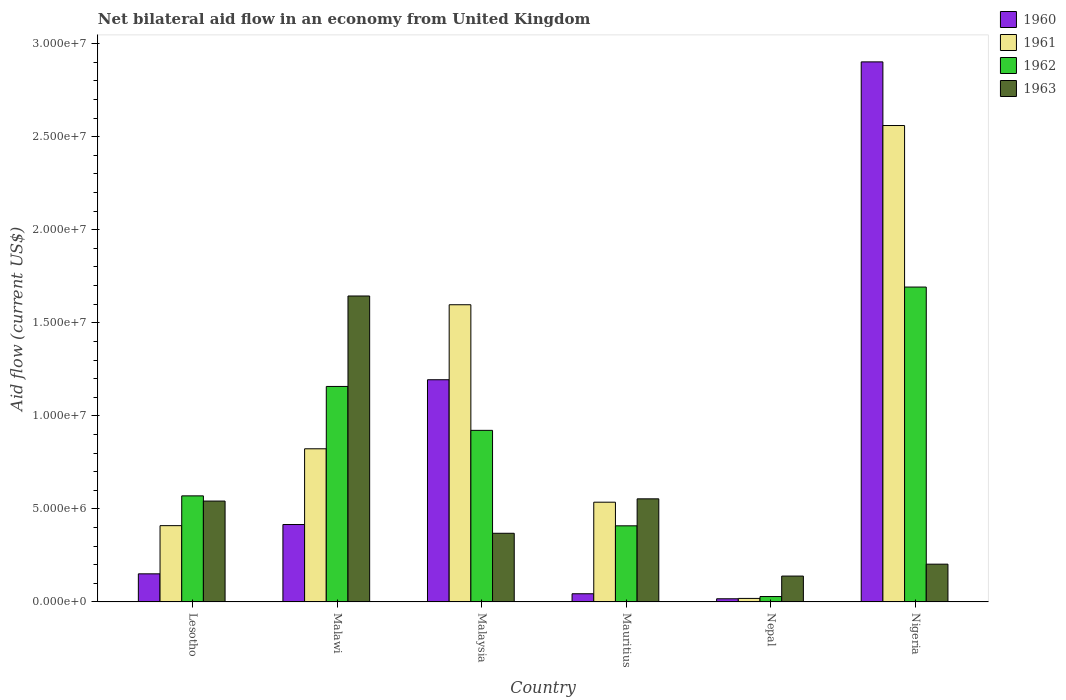Are the number of bars per tick equal to the number of legend labels?
Your response must be concise. Yes. What is the label of the 3rd group of bars from the left?
Offer a very short reply. Malaysia. In how many cases, is the number of bars for a given country not equal to the number of legend labels?
Offer a terse response. 0. Across all countries, what is the maximum net bilateral aid flow in 1963?
Make the answer very short. 1.64e+07. In which country was the net bilateral aid flow in 1963 maximum?
Keep it short and to the point. Malawi. In which country was the net bilateral aid flow in 1963 minimum?
Your answer should be compact. Nepal. What is the total net bilateral aid flow in 1962 in the graph?
Your answer should be very brief. 4.78e+07. What is the difference between the net bilateral aid flow in 1962 in Lesotho and that in Nepal?
Keep it short and to the point. 5.41e+06. What is the difference between the net bilateral aid flow in 1961 in Nigeria and the net bilateral aid flow in 1963 in Malaysia?
Offer a very short reply. 2.19e+07. What is the average net bilateral aid flow in 1961 per country?
Make the answer very short. 9.91e+06. What is the difference between the net bilateral aid flow of/in 1963 and net bilateral aid flow of/in 1960 in Lesotho?
Your answer should be very brief. 3.91e+06. What is the ratio of the net bilateral aid flow in 1963 in Lesotho to that in Nigeria?
Offer a terse response. 2.67. What is the difference between the highest and the second highest net bilateral aid flow in 1960?
Your answer should be very brief. 2.49e+07. What is the difference between the highest and the lowest net bilateral aid flow in 1960?
Keep it short and to the point. 2.88e+07. In how many countries, is the net bilateral aid flow in 1962 greater than the average net bilateral aid flow in 1962 taken over all countries?
Ensure brevity in your answer.  3. Is it the case that in every country, the sum of the net bilateral aid flow in 1963 and net bilateral aid flow in 1961 is greater than the sum of net bilateral aid flow in 1960 and net bilateral aid flow in 1962?
Offer a very short reply. No. What does the 3rd bar from the left in Lesotho represents?
Give a very brief answer. 1962. Are all the bars in the graph horizontal?
Your answer should be compact. No. How many countries are there in the graph?
Your response must be concise. 6. What is the difference between two consecutive major ticks on the Y-axis?
Your answer should be compact. 5.00e+06. Are the values on the major ticks of Y-axis written in scientific E-notation?
Give a very brief answer. Yes. Where does the legend appear in the graph?
Offer a very short reply. Top right. What is the title of the graph?
Your answer should be compact. Net bilateral aid flow in an economy from United Kingdom. What is the label or title of the X-axis?
Keep it short and to the point. Country. What is the Aid flow (current US$) in 1960 in Lesotho?
Give a very brief answer. 1.51e+06. What is the Aid flow (current US$) of 1961 in Lesotho?
Offer a terse response. 4.10e+06. What is the Aid flow (current US$) of 1962 in Lesotho?
Provide a succinct answer. 5.70e+06. What is the Aid flow (current US$) in 1963 in Lesotho?
Offer a very short reply. 5.42e+06. What is the Aid flow (current US$) in 1960 in Malawi?
Offer a very short reply. 4.16e+06. What is the Aid flow (current US$) of 1961 in Malawi?
Offer a terse response. 8.23e+06. What is the Aid flow (current US$) of 1962 in Malawi?
Provide a short and direct response. 1.16e+07. What is the Aid flow (current US$) in 1963 in Malawi?
Make the answer very short. 1.64e+07. What is the Aid flow (current US$) in 1960 in Malaysia?
Your response must be concise. 1.19e+07. What is the Aid flow (current US$) of 1961 in Malaysia?
Offer a terse response. 1.60e+07. What is the Aid flow (current US$) of 1962 in Malaysia?
Your answer should be very brief. 9.22e+06. What is the Aid flow (current US$) of 1963 in Malaysia?
Keep it short and to the point. 3.69e+06. What is the Aid flow (current US$) of 1961 in Mauritius?
Offer a very short reply. 5.36e+06. What is the Aid flow (current US$) in 1962 in Mauritius?
Give a very brief answer. 4.09e+06. What is the Aid flow (current US$) in 1963 in Mauritius?
Offer a terse response. 5.54e+06. What is the Aid flow (current US$) of 1961 in Nepal?
Offer a terse response. 1.90e+05. What is the Aid flow (current US$) in 1962 in Nepal?
Keep it short and to the point. 2.90e+05. What is the Aid flow (current US$) of 1963 in Nepal?
Offer a very short reply. 1.39e+06. What is the Aid flow (current US$) of 1960 in Nigeria?
Provide a short and direct response. 2.90e+07. What is the Aid flow (current US$) of 1961 in Nigeria?
Provide a short and direct response. 2.56e+07. What is the Aid flow (current US$) in 1962 in Nigeria?
Offer a very short reply. 1.69e+07. What is the Aid flow (current US$) in 1963 in Nigeria?
Give a very brief answer. 2.03e+06. Across all countries, what is the maximum Aid flow (current US$) in 1960?
Your response must be concise. 2.90e+07. Across all countries, what is the maximum Aid flow (current US$) in 1961?
Your answer should be compact. 2.56e+07. Across all countries, what is the maximum Aid flow (current US$) in 1962?
Your response must be concise. 1.69e+07. Across all countries, what is the maximum Aid flow (current US$) in 1963?
Your response must be concise. 1.64e+07. Across all countries, what is the minimum Aid flow (current US$) of 1960?
Give a very brief answer. 1.70e+05. Across all countries, what is the minimum Aid flow (current US$) of 1962?
Your answer should be compact. 2.90e+05. Across all countries, what is the minimum Aid flow (current US$) of 1963?
Make the answer very short. 1.39e+06. What is the total Aid flow (current US$) of 1960 in the graph?
Make the answer very short. 4.72e+07. What is the total Aid flow (current US$) of 1961 in the graph?
Ensure brevity in your answer.  5.94e+07. What is the total Aid flow (current US$) of 1962 in the graph?
Your answer should be very brief. 4.78e+07. What is the total Aid flow (current US$) in 1963 in the graph?
Your answer should be compact. 3.45e+07. What is the difference between the Aid flow (current US$) in 1960 in Lesotho and that in Malawi?
Provide a short and direct response. -2.65e+06. What is the difference between the Aid flow (current US$) in 1961 in Lesotho and that in Malawi?
Give a very brief answer. -4.13e+06. What is the difference between the Aid flow (current US$) in 1962 in Lesotho and that in Malawi?
Provide a short and direct response. -5.88e+06. What is the difference between the Aid flow (current US$) of 1963 in Lesotho and that in Malawi?
Make the answer very short. -1.10e+07. What is the difference between the Aid flow (current US$) of 1960 in Lesotho and that in Malaysia?
Make the answer very short. -1.04e+07. What is the difference between the Aid flow (current US$) of 1961 in Lesotho and that in Malaysia?
Offer a terse response. -1.19e+07. What is the difference between the Aid flow (current US$) of 1962 in Lesotho and that in Malaysia?
Your response must be concise. -3.52e+06. What is the difference between the Aid flow (current US$) in 1963 in Lesotho and that in Malaysia?
Provide a succinct answer. 1.73e+06. What is the difference between the Aid flow (current US$) in 1960 in Lesotho and that in Mauritius?
Offer a very short reply. 1.07e+06. What is the difference between the Aid flow (current US$) in 1961 in Lesotho and that in Mauritius?
Give a very brief answer. -1.26e+06. What is the difference between the Aid flow (current US$) in 1962 in Lesotho and that in Mauritius?
Keep it short and to the point. 1.61e+06. What is the difference between the Aid flow (current US$) in 1963 in Lesotho and that in Mauritius?
Keep it short and to the point. -1.20e+05. What is the difference between the Aid flow (current US$) in 1960 in Lesotho and that in Nepal?
Your response must be concise. 1.34e+06. What is the difference between the Aid flow (current US$) in 1961 in Lesotho and that in Nepal?
Make the answer very short. 3.91e+06. What is the difference between the Aid flow (current US$) of 1962 in Lesotho and that in Nepal?
Ensure brevity in your answer.  5.41e+06. What is the difference between the Aid flow (current US$) in 1963 in Lesotho and that in Nepal?
Provide a succinct answer. 4.03e+06. What is the difference between the Aid flow (current US$) of 1960 in Lesotho and that in Nigeria?
Your answer should be very brief. -2.75e+07. What is the difference between the Aid flow (current US$) in 1961 in Lesotho and that in Nigeria?
Offer a very short reply. -2.15e+07. What is the difference between the Aid flow (current US$) in 1962 in Lesotho and that in Nigeria?
Your answer should be compact. -1.12e+07. What is the difference between the Aid flow (current US$) of 1963 in Lesotho and that in Nigeria?
Give a very brief answer. 3.39e+06. What is the difference between the Aid flow (current US$) of 1960 in Malawi and that in Malaysia?
Give a very brief answer. -7.78e+06. What is the difference between the Aid flow (current US$) of 1961 in Malawi and that in Malaysia?
Your answer should be very brief. -7.74e+06. What is the difference between the Aid flow (current US$) of 1962 in Malawi and that in Malaysia?
Provide a short and direct response. 2.36e+06. What is the difference between the Aid flow (current US$) in 1963 in Malawi and that in Malaysia?
Keep it short and to the point. 1.28e+07. What is the difference between the Aid flow (current US$) of 1960 in Malawi and that in Mauritius?
Your answer should be very brief. 3.72e+06. What is the difference between the Aid flow (current US$) of 1961 in Malawi and that in Mauritius?
Your answer should be very brief. 2.87e+06. What is the difference between the Aid flow (current US$) of 1962 in Malawi and that in Mauritius?
Your answer should be very brief. 7.49e+06. What is the difference between the Aid flow (current US$) in 1963 in Malawi and that in Mauritius?
Make the answer very short. 1.09e+07. What is the difference between the Aid flow (current US$) in 1960 in Malawi and that in Nepal?
Offer a very short reply. 3.99e+06. What is the difference between the Aid flow (current US$) of 1961 in Malawi and that in Nepal?
Your response must be concise. 8.04e+06. What is the difference between the Aid flow (current US$) of 1962 in Malawi and that in Nepal?
Give a very brief answer. 1.13e+07. What is the difference between the Aid flow (current US$) in 1963 in Malawi and that in Nepal?
Give a very brief answer. 1.50e+07. What is the difference between the Aid flow (current US$) of 1960 in Malawi and that in Nigeria?
Your answer should be very brief. -2.49e+07. What is the difference between the Aid flow (current US$) in 1961 in Malawi and that in Nigeria?
Offer a terse response. -1.74e+07. What is the difference between the Aid flow (current US$) in 1962 in Malawi and that in Nigeria?
Provide a short and direct response. -5.34e+06. What is the difference between the Aid flow (current US$) of 1963 in Malawi and that in Nigeria?
Offer a very short reply. 1.44e+07. What is the difference between the Aid flow (current US$) in 1960 in Malaysia and that in Mauritius?
Keep it short and to the point. 1.15e+07. What is the difference between the Aid flow (current US$) in 1961 in Malaysia and that in Mauritius?
Give a very brief answer. 1.06e+07. What is the difference between the Aid flow (current US$) in 1962 in Malaysia and that in Mauritius?
Your answer should be very brief. 5.13e+06. What is the difference between the Aid flow (current US$) of 1963 in Malaysia and that in Mauritius?
Offer a very short reply. -1.85e+06. What is the difference between the Aid flow (current US$) of 1960 in Malaysia and that in Nepal?
Offer a very short reply. 1.18e+07. What is the difference between the Aid flow (current US$) of 1961 in Malaysia and that in Nepal?
Provide a short and direct response. 1.58e+07. What is the difference between the Aid flow (current US$) of 1962 in Malaysia and that in Nepal?
Your response must be concise. 8.93e+06. What is the difference between the Aid flow (current US$) of 1963 in Malaysia and that in Nepal?
Provide a short and direct response. 2.30e+06. What is the difference between the Aid flow (current US$) of 1960 in Malaysia and that in Nigeria?
Give a very brief answer. -1.71e+07. What is the difference between the Aid flow (current US$) in 1961 in Malaysia and that in Nigeria?
Your answer should be very brief. -9.63e+06. What is the difference between the Aid flow (current US$) of 1962 in Malaysia and that in Nigeria?
Keep it short and to the point. -7.70e+06. What is the difference between the Aid flow (current US$) of 1963 in Malaysia and that in Nigeria?
Your answer should be very brief. 1.66e+06. What is the difference between the Aid flow (current US$) of 1960 in Mauritius and that in Nepal?
Offer a very short reply. 2.70e+05. What is the difference between the Aid flow (current US$) of 1961 in Mauritius and that in Nepal?
Keep it short and to the point. 5.17e+06. What is the difference between the Aid flow (current US$) of 1962 in Mauritius and that in Nepal?
Provide a succinct answer. 3.80e+06. What is the difference between the Aid flow (current US$) in 1963 in Mauritius and that in Nepal?
Provide a short and direct response. 4.15e+06. What is the difference between the Aid flow (current US$) of 1960 in Mauritius and that in Nigeria?
Offer a terse response. -2.86e+07. What is the difference between the Aid flow (current US$) of 1961 in Mauritius and that in Nigeria?
Your answer should be compact. -2.02e+07. What is the difference between the Aid flow (current US$) of 1962 in Mauritius and that in Nigeria?
Make the answer very short. -1.28e+07. What is the difference between the Aid flow (current US$) in 1963 in Mauritius and that in Nigeria?
Ensure brevity in your answer.  3.51e+06. What is the difference between the Aid flow (current US$) in 1960 in Nepal and that in Nigeria?
Ensure brevity in your answer.  -2.88e+07. What is the difference between the Aid flow (current US$) of 1961 in Nepal and that in Nigeria?
Ensure brevity in your answer.  -2.54e+07. What is the difference between the Aid flow (current US$) of 1962 in Nepal and that in Nigeria?
Give a very brief answer. -1.66e+07. What is the difference between the Aid flow (current US$) of 1963 in Nepal and that in Nigeria?
Your answer should be compact. -6.40e+05. What is the difference between the Aid flow (current US$) in 1960 in Lesotho and the Aid flow (current US$) in 1961 in Malawi?
Your answer should be compact. -6.72e+06. What is the difference between the Aid flow (current US$) of 1960 in Lesotho and the Aid flow (current US$) of 1962 in Malawi?
Offer a terse response. -1.01e+07. What is the difference between the Aid flow (current US$) of 1960 in Lesotho and the Aid flow (current US$) of 1963 in Malawi?
Your response must be concise. -1.49e+07. What is the difference between the Aid flow (current US$) in 1961 in Lesotho and the Aid flow (current US$) in 1962 in Malawi?
Your response must be concise. -7.48e+06. What is the difference between the Aid flow (current US$) of 1961 in Lesotho and the Aid flow (current US$) of 1963 in Malawi?
Your answer should be very brief. -1.23e+07. What is the difference between the Aid flow (current US$) of 1962 in Lesotho and the Aid flow (current US$) of 1963 in Malawi?
Give a very brief answer. -1.07e+07. What is the difference between the Aid flow (current US$) in 1960 in Lesotho and the Aid flow (current US$) in 1961 in Malaysia?
Make the answer very short. -1.45e+07. What is the difference between the Aid flow (current US$) in 1960 in Lesotho and the Aid flow (current US$) in 1962 in Malaysia?
Your response must be concise. -7.71e+06. What is the difference between the Aid flow (current US$) of 1960 in Lesotho and the Aid flow (current US$) of 1963 in Malaysia?
Offer a very short reply. -2.18e+06. What is the difference between the Aid flow (current US$) in 1961 in Lesotho and the Aid flow (current US$) in 1962 in Malaysia?
Give a very brief answer. -5.12e+06. What is the difference between the Aid flow (current US$) in 1962 in Lesotho and the Aid flow (current US$) in 1963 in Malaysia?
Ensure brevity in your answer.  2.01e+06. What is the difference between the Aid flow (current US$) of 1960 in Lesotho and the Aid flow (current US$) of 1961 in Mauritius?
Offer a terse response. -3.85e+06. What is the difference between the Aid flow (current US$) in 1960 in Lesotho and the Aid flow (current US$) in 1962 in Mauritius?
Offer a very short reply. -2.58e+06. What is the difference between the Aid flow (current US$) in 1960 in Lesotho and the Aid flow (current US$) in 1963 in Mauritius?
Provide a short and direct response. -4.03e+06. What is the difference between the Aid flow (current US$) of 1961 in Lesotho and the Aid flow (current US$) of 1962 in Mauritius?
Offer a very short reply. 10000. What is the difference between the Aid flow (current US$) in 1961 in Lesotho and the Aid flow (current US$) in 1963 in Mauritius?
Offer a terse response. -1.44e+06. What is the difference between the Aid flow (current US$) in 1960 in Lesotho and the Aid flow (current US$) in 1961 in Nepal?
Your answer should be very brief. 1.32e+06. What is the difference between the Aid flow (current US$) in 1960 in Lesotho and the Aid flow (current US$) in 1962 in Nepal?
Keep it short and to the point. 1.22e+06. What is the difference between the Aid flow (current US$) of 1960 in Lesotho and the Aid flow (current US$) of 1963 in Nepal?
Offer a terse response. 1.20e+05. What is the difference between the Aid flow (current US$) in 1961 in Lesotho and the Aid flow (current US$) in 1962 in Nepal?
Provide a short and direct response. 3.81e+06. What is the difference between the Aid flow (current US$) in 1961 in Lesotho and the Aid flow (current US$) in 1963 in Nepal?
Provide a succinct answer. 2.71e+06. What is the difference between the Aid flow (current US$) in 1962 in Lesotho and the Aid flow (current US$) in 1963 in Nepal?
Your answer should be very brief. 4.31e+06. What is the difference between the Aid flow (current US$) of 1960 in Lesotho and the Aid flow (current US$) of 1961 in Nigeria?
Your answer should be compact. -2.41e+07. What is the difference between the Aid flow (current US$) in 1960 in Lesotho and the Aid flow (current US$) in 1962 in Nigeria?
Make the answer very short. -1.54e+07. What is the difference between the Aid flow (current US$) of 1960 in Lesotho and the Aid flow (current US$) of 1963 in Nigeria?
Ensure brevity in your answer.  -5.20e+05. What is the difference between the Aid flow (current US$) in 1961 in Lesotho and the Aid flow (current US$) in 1962 in Nigeria?
Your response must be concise. -1.28e+07. What is the difference between the Aid flow (current US$) in 1961 in Lesotho and the Aid flow (current US$) in 1963 in Nigeria?
Make the answer very short. 2.07e+06. What is the difference between the Aid flow (current US$) of 1962 in Lesotho and the Aid flow (current US$) of 1963 in Nigeria?
Keep it short and to the point. 3.67e+06. What is the difference between the Aid flow (current US$) in 1960 in Malawi and the Aid flow (current US$) in 1961 in Malaysia?
Provide a short and direct response. -1.18e+07. What is the difference between the Aid flow (current US$) in 1960 in Malawi and the Aid flow (current US$) in 1962 in Malaysia?
Your response must be concise. -5.06e+06. What is the difference between the Aid flow (current US$) of 1961 in Malawi and the Aid flow (current US$) of 1962 in Malaysia?
Provide a short and direct response. -9.90e+05. What is the difference between the Aid flow (current US$) in 1961 in Malawi and the Aid flow (current US$) in 1963 in Malaysia?
Your response must be concise. 4.54e+06. What is the difference between the Aid flow (current US$) in 1962 in Malawi and the Aid flow (current US$) in 1963 in Malaysia?
Provide a short and direct response. 7.89e+06. What is the difference between the Aid flow (current US$) in 1960 in Malawi and the Aid flow (current US$) in 1961 in Mauritius?
Provide a succinct answer. -1.20e+06. What is the difference between the Aid flow (current US$) of 1960 in Malawi and the Aid flow (current US$) of 1963 in Mauritius?
Make the answer very short. -1.38e+06. What is the difference between the Aid flow (current US$) of 1961 in Malawi and the Aid flow (current US$) of 1962 in Mauritius?
Give a very brief answer. 4.14e+06. What is the difference between the Aid flow (current US$) in 1961 in Malawi and the Aid flow (current US$) in 1963 in Mauritius?
Your answer should be compact. 2.69e+06. What is the difference between the Aid flow (current US$) in 1962 in Malawi and the Aid flow (current US$) in 1963 in Mauritius?
Your answer should be compact. 6.04e+06. What is the difference between the Aid flow (current US$) in 1960 in Malawi and the Aid flow (current US$) in 1961 in Nepal?
Offer a very short reply. 3.97e+06. What is the difference between the Aid flow (current US$) in 1960 in Malawi and the Aid flow (current US$) in 1962 in Nepal?
Your response must be concise. 3.87e+06. What is the difference between the Aid flow (current US$) of 1960 in Malawi and the Aid flow (current US$) of 1963 in Nepal?
Your answer should be very brief. 2.77e+06. What is the difference between the Aid flow (current US$) of 1961 in Malawi and the Aid flow (current US$) of 1962 in Nepal?
Ensure brevity in your answer.  7.94e+06. What is the difference between the Aid flow (current US$) of 1961 in Malawi and the Aid flow (current US$) of 1963 in Nepal?
Your answer should be compact. 6.84e+06. What is the difference between the Aid flow (current US$) in 1962 in Malawi and the Aid flow (current US$) in 1963 in Nepal?
Ensure brevity in your answer.  1.02e+07. What is the difference between the Aid flow (current US$) in 1960 in Malawi and the Aid flow (current US$) in 1961 in Nigeria?
Your response must be concise. -2.14e+07. What is the difference between the Aid flow (current US$) in 1960 in Malawi and the Aid flow (current US$) in 1962 in Nigeria?
Give a very brief answer. -1.28e+07. What is the difference between the Aid flow (current US$) of 1960 in Malawi and the Aid flow (current US$) of 1963 in Nigeria?
Your answer should be compact. 2.13e+06. What is the difference between the Aid flow (current US$) of 1961 in Malawi and the Aid flow (current US$) of 1962 in Nigeria?
Keep it short and to the point. -8.69e+06. What is the difference between the Aid flow (current US$) of 1961 in Malawi and the Aid flow (current US$) of 1963 in Nigeria?
Provide a succinct answer. 6.20e+06. What is the difference between the Aid flow (current US$) in 1962 in Malawi and the Aid flow (current US$) in 1963 in Nigeria?
Make the answer very short. 9.55e+06. What is the difference between the Aid flow (current US$) of 1960 in Malaysia and the Aid flow (current US$) of 1961 in Mauritius?
Keep it short and to the point. 6.58e+06. What is the difference between the Aid flow (current US$) in 1960 in Malaysia and the Aid flow (current US$) in 1962 in Mauritius?
Your response must be concise. 7.85e+06. What is the difference between the Aid flow (current US$) in 1960 in Malaysia and the Aid flow (current US$) in 1963 in Mauritius?
Provide a succinct answer. 6.40e+06. What is the difference between the Aid flow (current US$) of 1961 in Malaysia and the Aid flow (current US$) of 1962 in Mauritius?
Ensure brevity in your answer.  1.19e+07. What is the difference between the Aid flow (current US$) of 1961 in Malaysia and the Aid flow (current US$) of 1963 in Mauritius?
Make the answer very short. 1.04e+07. What is the difference between the Aid flow (current US$) in 1962 in Malaysia and the Aid flow (current US$) in 1963 in Mauritius?
Provide a short and direct response. 3.68e+06. What is the difference between the Aid flow (current US$) of 1960 in Malaysia and the Aid flow (current US$) of 1961 in Nepal?
Your answer should be compact. 1.18e+07. What is the difference between the Aid flow (current US$) in 1960 in Malaysia and the Aid flow (current US$) in 1962 in Nepal?
Your answer should be compact. 1.16e+07. What is the difference between the Aid flow (current US$) in 1960 in Malaysia and the Aid flow (current US$) in 1963 in Nepal?
Ensure brevity in your answer.  1.06e+07. What is the difference between the Aid flow (current US$) in 1961 in Malaysia and the Aid flow (current US$) in 1962 in Nepal?
Provide a succinct answer. 1.57e+07. What is the difference between the Aid flow (current US$) in 1961 in Malaysia and the Aid flow (current US$) in 1963 in Nepal?
Offer a very short reply. 1.46e+07. What is the difference between the Aid flow (current US$) of 1962 in Malaysia and the Aid flow (current US$) of 1963 in Nepal?
Give a very brief answer. 7.83e+06. What is the difference between the Aid flow (current US$) of 1960 in Malaysia and the Aid flow (current US$) of 1961 in Nigeria?
Your answer should be compact. -1.37e+07. What is the difference between the Aid flow (current US$) of 1960 in Malaysia and the Aid flow (current US$) of 1962 in Nigeria?
Provide a short and direct response. -4.98e+06. What is the difference between the Aid flow (current US$) of 1960 in Malaysia and the Aid flow (current US$) of 1963 in Nigeria?
Your answer should be compact. 9.91e+06. What is the difference between the Aid flow (current US$) of 1961 in Malaysia and the Aid flow (current US$) of 1962 in Nigeria?
Ensure brevity in your answer.  -9.50e+05. What is the difference between the Aid flow (current US$) in 1961 in Malaysia and the Aid flow (current US$) in 1963 in Nigeria?
Provide a succinct answer. 1.39e+07. What is the difference between the Aid flow (current US$) in 1962 in Malaysia and the Aid flow (current US$) in 1963 in Nigeria?
Provide a short and direct response. 7.19e+06. What is the difference between the Aid flow (current US$) in 1960 in Mauritius and the Aid flow (current US$) in 1961 in Nepal?
Offer a terse response. 2.50e+05. What is the difference between the Aid flow (current US$) in 1960 in Mauritius and the Aid flow (current US$) in 1962 in Nepal?
Offer a terse response. 1.50e+05. What is the difference between the Aid flow (current US$) of 1960 in Mauritius and the Aid flow (current US$) of 1963 in Nepal?
Ensure brevity in your answer.  -9.50e+05. What is the difference between the Aid flow (current US$) of 1961 in Mauritius and the Aid flow (current US$) of 1962 in Nepal?
Make the answer very short. 5.07e+06. What is the difference between the Aid flow (current US$) in 1961 in Mauritius and the Aid flow (current US$) in 1963 in Nepal?
Make the answer very short. 3.97e+06. What is the difference between the Aid flow (current US$) in 1962 in Mauritius and the Aid flow (current US$) in 1963 in Nepal?
Keep it short and to the point. 2.70e+06. What is the difference between the Aid flow (current US$) in 1960 in Mauritius and the Aid flow (current US$) in 1961 in Nigeria?
Offer a very short reply. -2.52e+07. What is the difference between the Aid flow (current US$) of 1960 in Mauritius and the Aid flow (current US$) of 1962 in Nigeria?
Offer a terse response. -1.65e+07. What is the difference between the Aid flow (current US$) of 1960 in Mauritius and the Aid flow (current US$) of 1963 in Nigeria?
Provide a succinct answer. -1.59e+06. What is the difference between the Aid flow (current US$) of 1961 in Mauritius and the Aid flow (current US$) of 1962 in Nigeria?
Your answer should be compact. -1.16e+07. What is the difference between the Aid flow (current US$) of 1961 in Mauritius and the Aid flow (current US$) of 1963 in Nigeria?
Your answer should be compact. 3.33e+06. What is the difference between the Aid flow (current US$) in 1962 in Mauritius and the Aid flow (current US$) in 1963 in Nigeria?
Keep it short and to the point. 2.06e+06. What is the difference between the Aid flow (current US$) in 1960 in Nepal and the Aid flow (current US$) in 1961 in Nigeria?
Provide a short and direct response. -2.54e+07. What is the difference between the Aid flow (current US$) of 1960 in Nepal and the Aid flow (current US$) of 1962 in Nigeria?
Your answer should be compact. -1.68e+07. What is the difference between the Aid flow (current US$) in 1960 in Nepal and the Aid flow (current US$) in 1963 in Nigeria?
Ensure brevity in your answer.  -1.86e+06. What is the difference between the Aid flow (current US$) in 1961 in Nepal and the Aid flow (current US$) in 1962 in Nigeria?
Your answer should be compact. -1.67e+07. What is the difference between the Aid flow (current US$) in 1961 in Nepal and the Aid flow (current US$) in 1963 in Nigeria?
Offer a very short reply. -1.84e+06. What is the difference between the Aid flow (current US$) in 1962 in Nepal and the Aid flow (current US$) in 1963 in Nigeria?
Your answer should be very brief. -1.74e+06. What is the average Aid flow (current US$) in 1960 per country?
Provide a short and direct response. 7.87e+06. What is the average Aid flow (current US$) in 1961 per country?
Give a very brief answer. 9.91e+06. What is the average Aid flow (current US$) of 1962 per country?
Ensure brevity in your answer.  7.97e+06. What is the average Aid flow (current US$) in 1963 per country?
Offer a terse response. 5.75e+06. What is the difference between the Aid flow (current US$) of 1960 and Aid flow (current US$) of 1961 in Lesotho?
Provide a succinct answer. -2.59e+06. What is the difference between the Aid flow (current US$) in 1960 and Aid flow (current US$) in 1962 in Lesotho?
Offer a very short reply. -4.19e+06. What is the difference between the Aid flow (current US$) of 1960 and Aid flow (current US$) of 1963 in Lesotho?
Provide a short and direct response. -3.91e+06. What is the difference between the Aid flow (current US$) in 1961 and Aid flow (current US$) in 1962 in Lesotho?
Provide a succinct answer. -1.60e+06. What is the difference between the Aid flow (current US$) of 1961 and Aid flow (current US$) of 1963 in Lesotho?
Make the answer very short. -1.32e+06. What is the difference between the Aid flow (current US$) in 1960 and Aid flow (current US$) in 1961 in Malawi?
Provide a succinct answer. -4.07e+06. What is the difference between the Aid flow (current US$) in 1960 and Aid flow (current US$) in 1962 in Malawi?
Offer a terse response. -7.42e+06. What is the difference between the Aid flow (current US$) of 1960 and Aid flow (current US$) of 1963 in Malawi?
Provide a succinct answer. -1.23e+07. What is the difference between the Aid flow (current US$) in 1961 and Aid flow (current US$) in 1962 in Malawi?
Give a very brief answer. -3.35e+06. What is the difference between the Aid flow (current US$) of 1961 and Aid flow (current US$) of 1963 in Malawi?
Your response must be concise. -8.21e+06. What is the difference between the Aid flow (current US$) of 1962 and Aid flow (current US$) of 1963 in Malawi?
Keep it short and to the point. -4.86e+06. What is the difference between the Aid flow (current US$) in 1960 and Aid flow (current US$) in 1961 in Malaysia?
Your answer should be compact. -4.03e+06. What is the difference between the Aid flow (current US$) of 1960 and Aid flow (current US$) of 1962 in Malaysia?
Give a very brief answer. 2.72e+06. What is the difference between the Aid flow (current US$) of 1960 and Aid flow (current US$) of 1963 in Malaysia?
Your response must be concise. 8.25e+06. What is the difference between the Aid flow (current US$) in 1961 and Aid flow (current US$) in 1962 in Malaysia?
Your answer should be very brief. 6.75e+06. What is the difference between the Aid flow (current US$) in 1961 and Aid flow (current US$) in 1963 in Malaysia?
Your answer should be very brief. 1.23e+07. What is the difference between the Aid flow (current US$) in 1962 and Aid flow (current US$) in 1963 in Malaysia?
Keep it short and to the point. 5.53e+06. What is the difference between the Aid flow (current US$) in 1960 and Aid flow (current US$) in 1961 in Mauritius?
Your response must be concise. -4.92e+06. What is the difference between the Aid flow (current US$) in 1960 and Aid flow (current US$) in 1962 in Mauritius?
Provide a short and direct response. -3.65e+06. What is the difference between the Aid flow (current US$) of 1960 and Aid flow (current US$) of 1963 in Mauritius?
Offer a very short reply. -5.10e+06. What is the difference between the Aid flow (current US$) in 1961 and Aid flow (current US$) in 1962 in Mauritius?
Your answer should be very brief. 1.27e+06. What is the difference between the Aid flow (current US$) of 1961 and Aid flow (current US$) of 1963 in Mauritius?
Give a very brief answer. -1.80e+05. What is the difference between the Aid flow (current US$) of 1962 and Aid flow (current US$) of 1963 in Mauritius?
Provide a short and direct response. -1.45e+06. What is the difference between the Aid flow (current US$) in 1960 and Aid flow (current US$) in 1963 in Nepal?
Your response must be concise. -1.22e+06. What is the difference between the Aid flow (current US$) in 1961 and Aid flow (current US$) in 1963 in Nepal?
Provide a short and direct response. -1.20e+06. What is the difference between the Aid flow (current US$) of 1962 and Aid flow (current US$) of 1963 in Nepal?
Offer a terse response. -1.10e+06. What is the difference between the Aid flow (current US$) of 1960 and Aid flow (current US$) of 1961 in Nigeria?
Provide a succinct answer. 3.42e+06. What is the difference between the Aid flow (current US$) of 1960 and Aid flow (current US$) of 1962 in Nigeria?
Your answer should be compact. 1.21e+07. What is the difference between the Aid flow (current US$) in 1960 and Aid flow (current US$) in 1963 in Nigeria?
Your response must be concise. 2.70e+07. What is the difference between the Aid flow (current US$) in 1961 and Aid flow (current US$) in 1962 in Nigeria?
Your answer should be very brief. 8.68e+06. What is the difference between the Aid flow (current US$) of 1961 and Aid flow (current US$) of 1963 in Nigeria?
Make the answer very short. 2.36e+07. What is the difference between the Aid flow (current US$) in 1962 and Aid flow (current US$) in 1963 in Nigeria?
Offer a terse response. 1.49e+07. What is the ratio of the Aid flow (current US$) of 1960 in Lesotho to that in Malawi?
Provide a short and direct response. 0.36. What is the ratio of the Aid flow (current US$) in 1961 in Lesotho to that in Malawi?
Make the answer very short. 0.5. What is the ratio of the Aid flow (current US$) of 1962 in Lesotho to that in Malawi?
Your response must be concise. 0.49. What is the ratio of the Aid flow (current US$) of 1963 in Lesotho to that in Malawi?
Your answer should be compact. 0.33. What is the ratio of the Aid flow (current US$) in 1960 in Lesotho to that in Malaysia?
Ensure brevity in your answer.  0.13. What is the ratio of the Aid flow (current US$) in 1961 in Lesotho to that in Malaysia?
Make the answer very short. 0.26. What is the ratio of the Aid flow (current US$) of 1962 in Lesotho to that in Malaysia?
Your answer should be compact. 0.62. What is the ratio of the Aid flow (current US$) of 1963 in Lesotho to that in Malaysia?
Ensure brevity in your answer.  1.47. What is the ratio of the Aid flow (current US$) in 1960 in Lesotho to that in Mauritius?
Make the answer very short. 3.43. What is the ratio of the Aid flow (current US$) of 1961 in Lesotho to that in Mauritius?
Provide a short and direct response. 0.76. What is the ratio of the Aid flow (current US$) of 1962 in Lesotho to that in Mauritius?
Ensure brevity in your answer.  1.39. What is the ratio of the Aid flow (current US$) of 1963 in Lesotho to that in Mauritius?
Provide a short and direct response. 0.98. What is the ratio of the Aid flow (current US$) in 1960 in Lesotho to that in Nepal?
Your answer should be compact. 8.88. What is the ratio of the Aid flow (current US$) of 1961 in Lesotho to that in Nepal?
Offer a terse response. 21.58. What is the ratio of the Aid flow (current US$) of 1962 in Lesotho to that in Nepal?
Provide a succinct answer. 19.66. What is the ratio of the Aid flow (current US$) in 1963 in Lesotho to that in Nepal?
Provide a short and direct response. 3.9. What is the ratio of the Aid flow (current US$) of 1960 in Lesotho to that in Nigeria?
Your answer should be very brief. 0.05. What is the ratio of the Aid flow (current US$) in 1961 in Lesotho to that in Nigeria?
Offer a terse response. 0.16. What is the ratio of the Aid flow (current US$) of 1962 in Lesotho to that in Nigeria?
Give a very brief answer. 0.34. What is the ratio of the Aid flow (current US$) of 1963 in Lesotho to that in Nigeria?
Make the answer very short. 2.67. What is the ratio of the Aid flow (current US$) of 1960 in Malawi to that in Malaysia?
Provide a short and direct response. 0.35. What is the ratio of the Aid flow (current US$) of 1961 in Malawi to that in Malaysia?
Your answer should be very brief. 0.52. What is the ratio of the Aid flow (current US$) of 1962 in Malawi to that in Malaysia?
Your answer should be compact. 1.26. What is the ratio of the Aid flow (current US$) of 1963 in Malawi to that in Malaysia?
Your response must be concise. 4.46. What is the ratio of the Aid flow (current US$) in 1960 in Malawi to that in Mauritius?
Make the answer very short. 9.45. What is the ratio of the Aid flow (current US$) in 1961 in Malawi to that in Mauritius?
Make the answer very short. 1.54. What is the ratio of the Aid flow (current US$) in 1962 in Malawi to that in Mauritius?
Provide a short and direct response. 2.83. What is the ratio of the Aid flow (current US$) of 1963 in Malawi to that in Mauritius?
Your response must be concise. 2.97. What is the ratio of the Aid flow (current US$) in 1960 in Malawi to that in Nepal?
Your answer should be very brief. 24.47. What is the ratio of the Aid flow (current US$) in 1961 in Malawi to that in Nepal?
Offer a terse response. 43.32. What is the ratio of the Aid flow (current US$) of 1962 in Malawi to that in Nepal?
Your answer should be very brief. 39.93. What is the ratio of the Aid flow (current US$) of 1963 in Malawi to that in Nepal?
Your response must be concise. 11.83. What is the ratio of the Aid flow (current US$) of 1960 in Malawi to that in Nigeria?
Give a very brief answer. 0.14. What is the ratio of the Aid flow (current US$) of 1961 in Malawi to that in Nigeria?
Ensure brevity in your answer.  0.32. What is the ratio of the Aid flow (current US$) of 1962 in Malawi to that in Nigeria?
Ensure brevity in your answer.  0.68. What is the ratio of the Aid flow (current US$) of 1963 in Malawi to that in Nigeria?
Your answer should be very brief. 8.1. What is the ratio of the Aid flow (current US$) in 1960 in Malaysia to that in Mauritius?
Offer a terse response. 27.14. What is the ratio of the Aid flow (current US$) of 1961 in Malaysia to that in Mauritius?
Offer a terse response. 2.98. What is the ratio of the Aid flow (current US$) of 1962 in Malaysia to that in Mauritius?
Your answer should be very brief. 2.25. What is the ratio of the Aid flow (current US$) in 1963 in Malaysia to that in Mauritius?
Provide a short and direct response. 0.67. What is the ratio of the Aid flow (current US$) of 1960 in Malaysia to that in Nepal?
Keep it short and to the point. 70.24. What is the ratio of the Aid flow (current US$) of 1961 in Malaysia to that in Nepal?
Give a very brief answer. 84.05. What is the ratio of the Aid flow (current US$) of 1962 in Malaysia to that in Nepal?
Provide a short and direct response. 31.79. What is the ratio of the Aid flow (current US$) of 1963 in Malaysia to that in Nepal?
Offer a very short reply. 2.65. What is the ratio of the Aid flow (current US$) of 1960 in Malaysia to that in Nigeria?
Make the answer very short. 0.41. What is the ratio of the Aid flow (current US$) of 1961 in Malaysia to that in Nigeria?
Ensure brevity in your answer.  0.62. What is the ratio of the Aid flow (current US$) of 1962 in Malaysia to that in Nigeria?
Make the answer very short. 0.54. What is the ratio of the Aid flow (current US$) in 1963 in Malaysia to that in Nigeria?
Give a very brief answer. 1.82. What is the ratio of the Aid flow (current US$) in 1960 in Mauritius to that in Nepal?
Offer a terse response. 2.59. What is the ratio of the Aid flow (current US$) in 1961 in Mauritius to that in Nepal?
Ensure brevity in your answer.  28.21. What is the ratio of the Aid flow (current US$) of 1962 in Mauritius to that in Nepal?
Your response must be concise. 14.1. What is the ratio of the Aid flow (current US$) in 1963 in Mauritius to that in Nepal?
Offer a terse response. 3.99. What is the ratio of the Aid flow (current US$) of 1960 in Mauritius to that in Nigeria?
Keep it short and to the point. 0.02. What is the ratio of the Aid flow (current US$) in 1961 in Mauritius to that in Nigeria?
Your response must be concise. 0.21. What is the ratio of the Aid flow (current US$) of 1962 in Mauritius to that in Nigeria?
Your answer should be very brief. 0.24. What is the ratio of the Aid flow (current US$) of 1963 in Mauritius to that in Nigeria?
Provide a succinct answer. 2.73. What is the ratio of the Aid flow (current US$) of 1960 in Nepal to that in Nigeria?
Make the answer very short. 0.01. What is the ratio of the Aid flow (current US$) of 1961 in Nepal to that in Nigeria?
Your response must be concise. 0.01. What is the ratio of the Aid flow (current US$) of 1962 in Nepal to that in Nigeria?
Keep it short and to the point. 0.02. What is the ratio of the Aid flow (current US$) in 1963 in Nepal to that in Nigeria?
Your answer should be very brief. 0.68. What is the difference between the highest and the second highest Aid flow (current US$) in 1960?
Your response must be concise. 1.71e+07. What is the difference between the highest and the second highest Aid flow (current US$) in 1961?
Offer a very short reply. 9.63e+06. What is the difference between the highest and the second highest Aid flow (current US$) in 1962?
Offer a very short reply. 5.34e+06. What is the difference between the highest and the second highest Aid flow (current US$) in 1963?
Your answer should be very brief. 1.09e+07. What is the difference between the highest and the lowest Aid flow (current US$) in 1960?
Ensure brevity in your answer.  2.88e+07. What is the difference between the highest and the lowest Aid flow (current US$) in 1961?
Your answer should be compact. 2.54e+07. What is the difference between the highest and the lowest Aid flow (current US$) in 1962?
Your response must be concise. 1.66e+07. What is the difference between the highest and the lowest Aid flow (current US$) in 1963?
Give a very brief answer. 1.50e+07. 